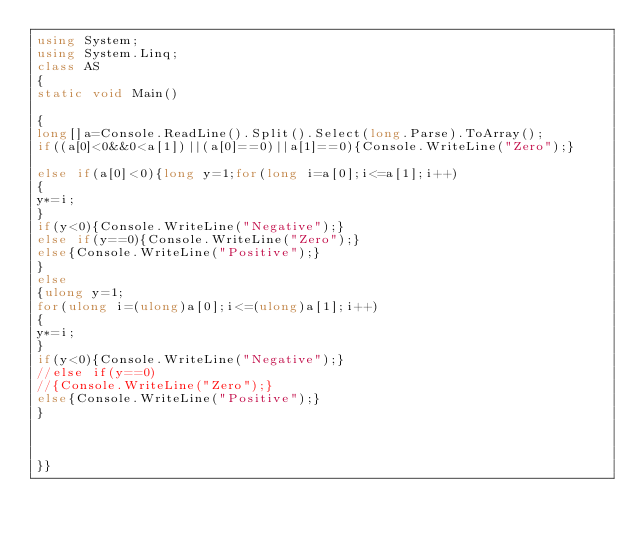Convert code to text. <code><loc_0><loc_0><loc_500><loc_500><_C#_>using System;
using System.Linq;
class AS
{
static void Main()

{
long[]a=Console.ReadLine().Split().Select(long.Parse).ToArray();
if((a[0]<0&&0<a[1])||(a[0]==0)||a[1]==0){Console.WriteLine("Zero");}

else if(a[0]<0){long y=1;for(long i=a[0];i<=a[1];i++)
{
y*=i;
}
if(y<0){Console.WriteLine("Negative");}
else if(y==0){Console.WriteLine("Zero");}
else{Console.WriteLine("Positive");}
}
else
{ulong y=1;
for(ulong i=(ulong)a[0];i<=(ulong)a[1];i++)
{
y*=i;
}
if(y<0){Console.WriteLine("Negative");}
//else if(y==0)
//{Console.WriteLine("Zero");}
else{Console.WriteLine("Positive");}
}



}}</code> 